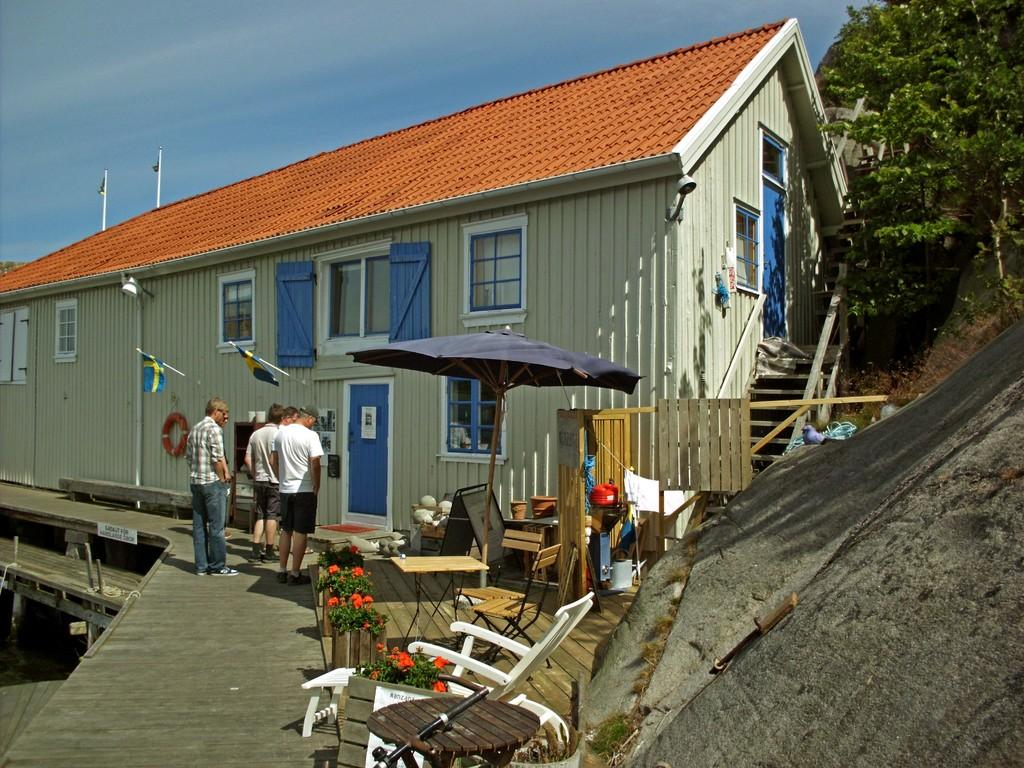What type of furniture is present in the image? There is a table and a chair in the image. What object related to plants can be seen in the image? There is a flower pot in the image. How many people are standing in the image? There are four members standing in the image. What type of building is visible in the image? There is a house in the image. What type of natural vegetation is present in the image? There are trees in the image. Can you see any fangs on the trees in the image? There are no fangs present on the trees in the image, as trees do not have fangs. What type of authority is depicted in the image? There is no authority figure or representation of authority present in the image. 